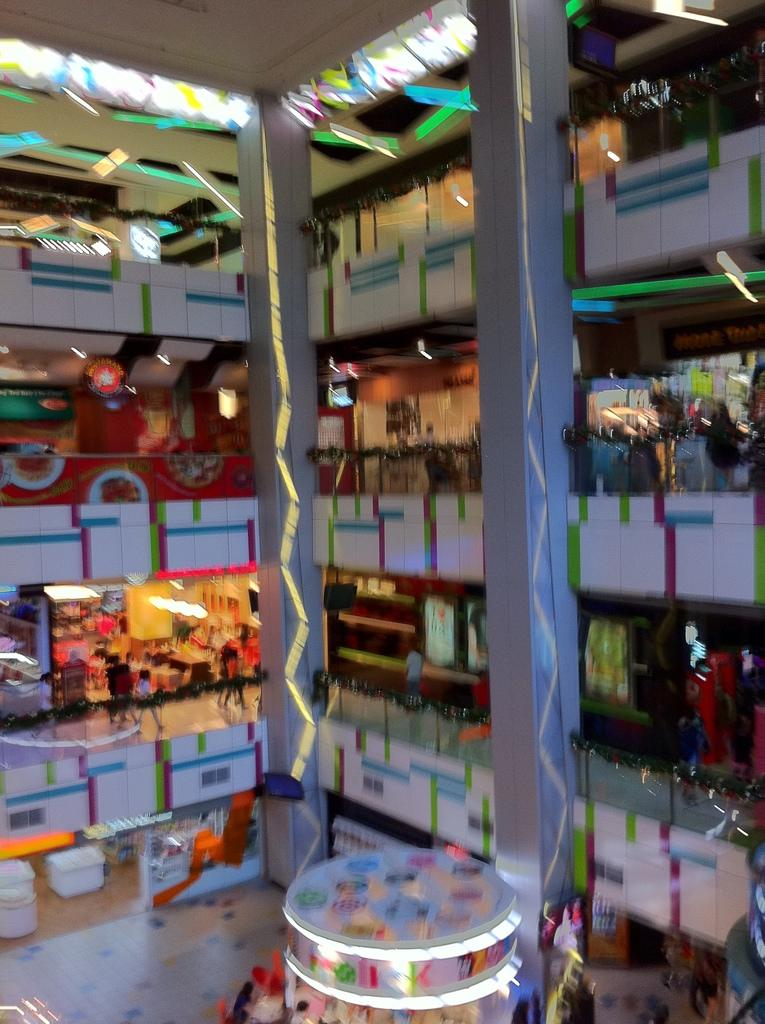What type of location is depicted in the image? The image appears to be an inside view of a shopping mall. Can you describe the people in the shopping mall? There are people in the shopping mall. What type of structure can be seen in the shopping mall? There is a fence in the shopping mall. What architectural features are present in the shopping mall? There are pillars in the shopping mall. What type of lighting is present in the shopping mall? There are lights in the shopping mall. What type of signage or advertisements are present in the shopping mall? There are boards in the shopping mall. What other objects can be seen in the shopping mall? There are other objects in the shopping mall. What type of poison is being sold in the shopping mall? There is no indication of any poison being sold in the shopping mall; the image only shows a general view of the mall's interior. 